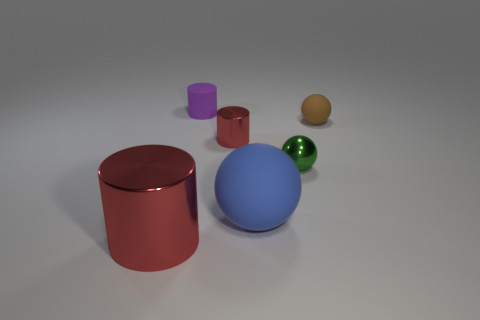How many tiny green balls are left of the tiny metallic thing that is left of the tiny green sphere?
Make the answer very short. 0. What number of balls are brown rubber things or red shiny objects?
Your answer should be very brief. 1. The tiny thing that is behind the tiny red shiny cylinder and to the left of the large blue sphere is what color?
Give a very brief answer. Purple. Is there any other thing of the same color as the big sphere?
Provide a succinct answer. No. There is a metal cylinder behind the big object to the left of the tiny shiny cylinder; what color is it?
Provide a short and direct response. Red. Is the size of the brown matte ball the same as the rubber cylinder?
Keep it short and to the point. Yes. Do the tiny sphere that is behind the tiny red metallic cylinder and the cylinder to the left of the small purple cylinder have the same material?
Your answer should be very brief. No. There is a small shiny thing that is behind the small shiny thing on the right side of the red metallic thing that is behind the big red object; what shape is it?
Offer a very short reply. Cylinder. Are there more small metal spheres than tiny blue cylinders?
Give a very brief answer. Yes. Are any small brown rubber things visible?
Provide a short and direct response. Yes. 